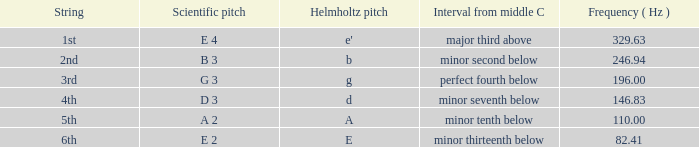I'm looking to parse the entire table for insights. Could you assist me with that? {'header': ['String', 'Scientific pitch', 'Helmholtz pitch', 'Interval from middle C', 'Frequency ( Hz )'], 'rows': [['1st', 'E 4', "e'", 'major third above', '329.63'], ['2nd', 'B 3', 'b', 'minor second below', '246.94'], ['3rd', 'G 3', 'g', 'perfect fourth below', '196.00'], ['4th', 'D 3', 'd', 'minor seventh below', '146.83'], ['5th', 'A 2', 'A', 'minor tenth below', '110.00'], ['6th', 'E 2', 'E', 'minor thirteenth below', '82.41']]} What is the lowest Frequency where the Hemholtz pitch is d? 146.83. 